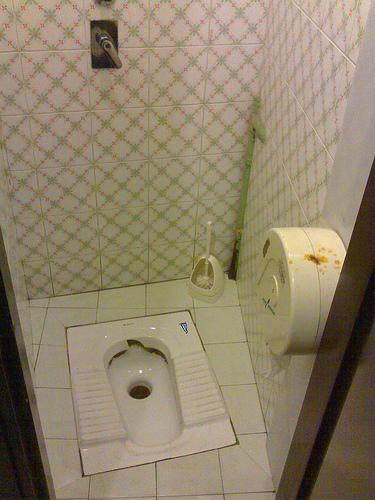Which image segmentation task can be performed with a focus on irregularities? Image anomaly detection task with a focus on cracks and holes in the tiles, and the vomit on the container. Identify the primary object in this dirty bathroom. A dirty white squat toilet is the primary object in the bathroom. What tool is seen for cleaning the toilet? A toilet bowl cleaning brush is in the corner. Specify a sentiment this image might evoke for someone using the bathroom. This image might evoke a feeling of disgust due to the dirty conditions. Name an article found nearby the main object (the toilet) in the image. A toilet paper dispenser is found nearby the toilet. Point out an object placed against the wall. A cane is placed against the wall. Describe the design present on the wall tiles. There are patterned tiles featuring pink and green designs on the bathroom wall. What type of object in this image helps in cleaning a toilet? A white plastic toilet bowl scrubber helps in cleaning the toilet. Mention one unsanitary aspect visible in the image. There is vomit on the toilet paper container. What feature of the toilet paper dispenser is damaged? There is a small hole in the toilet paper dispenser. 